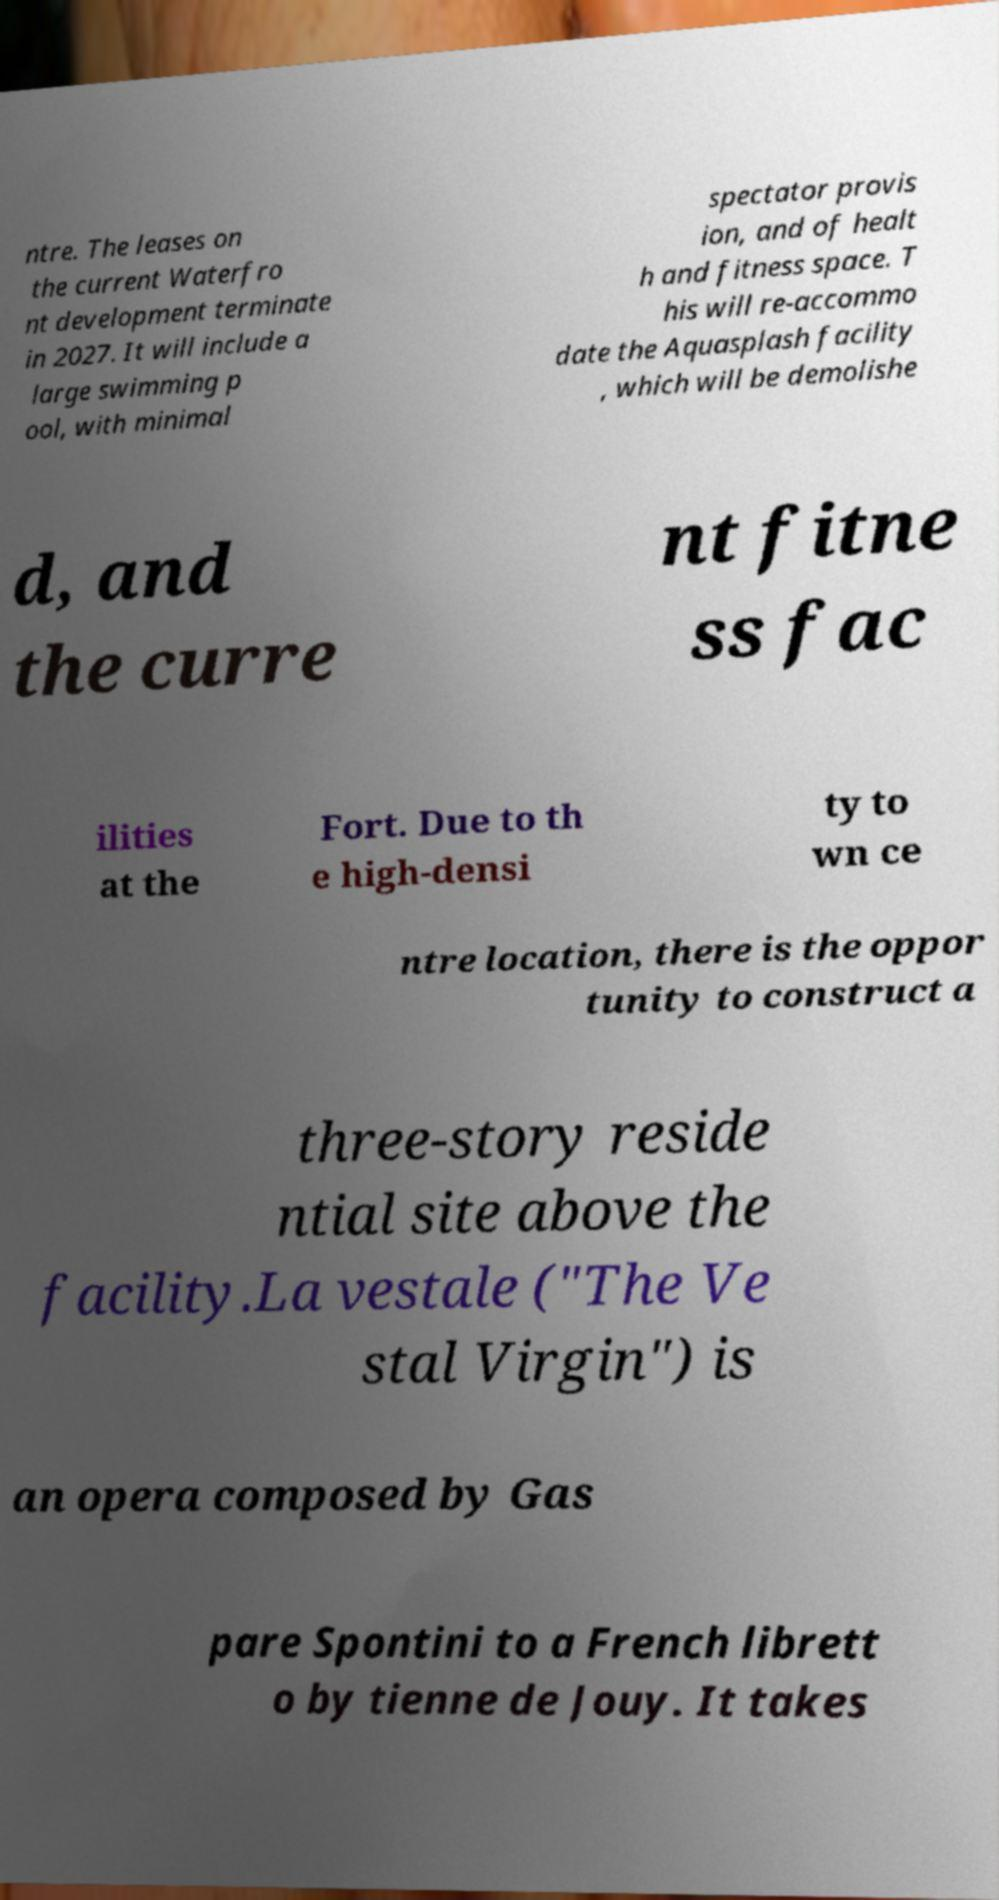Can you accurately transcribe the text from the provided image for me? ntre. The leases on the current Waterfro nt development terminate in 2027. It will include a large swimming p ool, with minimal spectator provis ion, and of healt h and fitness space. T his will re-accommo date the Aquasplash facility , which will be demolishe d, and the curre nt fitne ss fac ilities at the Fort. Due to th e high-densi ty to wn ce ntre location, there is the oppor tunity to construct a three-story reside ntial site above the facility.La vestale ("The Ve stal Virgin") is an opera composed by Gas pare Spontini to a French librett o by tienne de Jouy. It takes 